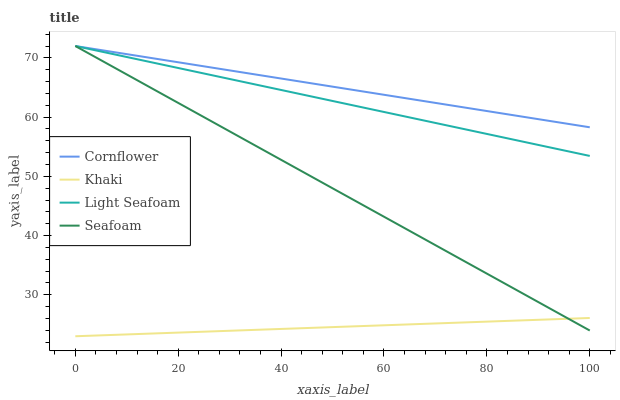Does Khaki have the minimum area under the curve?
Answer yes or no. Yes. Does Cornflower have the maximum area under the curve?
Answer yes or no. Yes. Does Seafoam have the minimum area under the curve?
Answer yes or no. No. Does Seafoam have the maximum area under the curve?
Answer yes or no. No. Is Khaki the smoothest?
Answer yes or no. Yes. Is Light Seafoam the roughest?
Answer yes or no. Yes. Is Seafoam the smoothest?
Answer yes or no. No. Is Seafoam the roughest?
Answer yes or no. No. Does Khaki have the lowest value?
Answer yes or no. Yes. Does Seafoam have the lowest value?
Answer yes or no. No. Does Light Seafoam have the highest value?
Answer yes or no. Yes. Does Khaki have the highest value?
Answer yes or no. No. Is Khaki less than Light Seafoam?
Answer yes or no. Yes. Is Cornflower greater than Khaki?
Answer yes or no. Yes. Does Seafoam intersect Light Seafoam?
Answer yes or no. Yes. Is Seafoam less than Light Seafoam?
Answer yes or no. No. Is Seafoam greater than Light Seafoam?
Answer yes or no. No. Does Khaki intersect Light Seafoam?
Answer yes or no. No. 